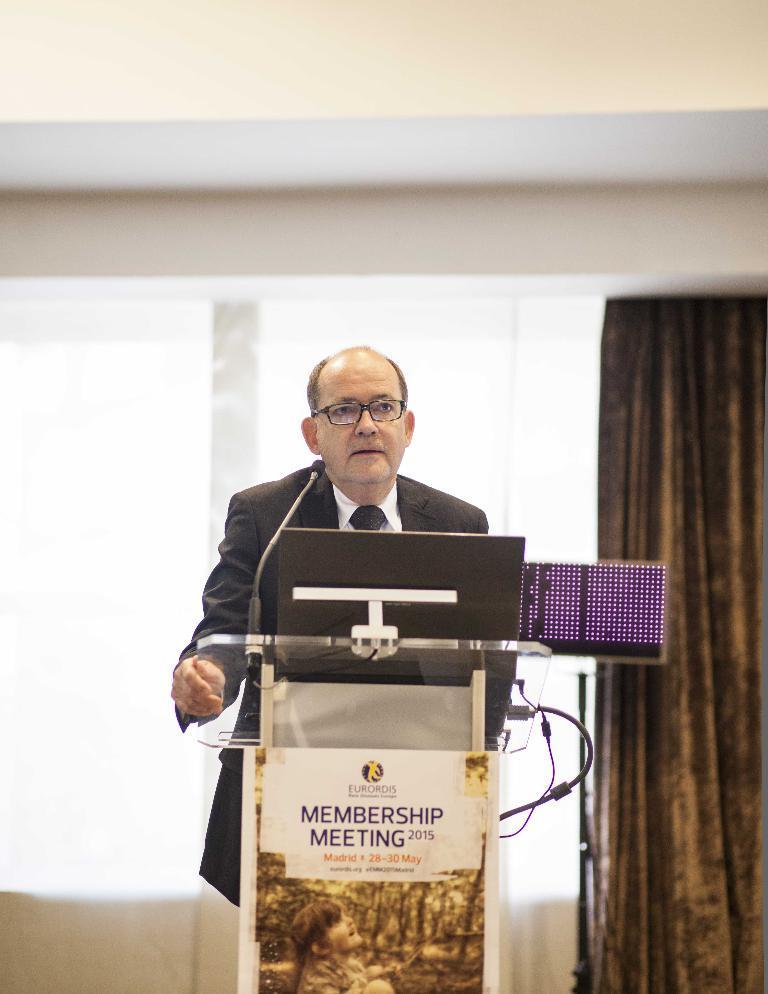Can you describe this image briefly? The man in the middle of the picture wearing a white shirt and black blazer is standing near the podium. On the podium, we see the microphone and laptop are placed. He is talking on the microphone. Behind him, we see the windows and a curtain in brown color. At the top of the picture, we see a white wall. 